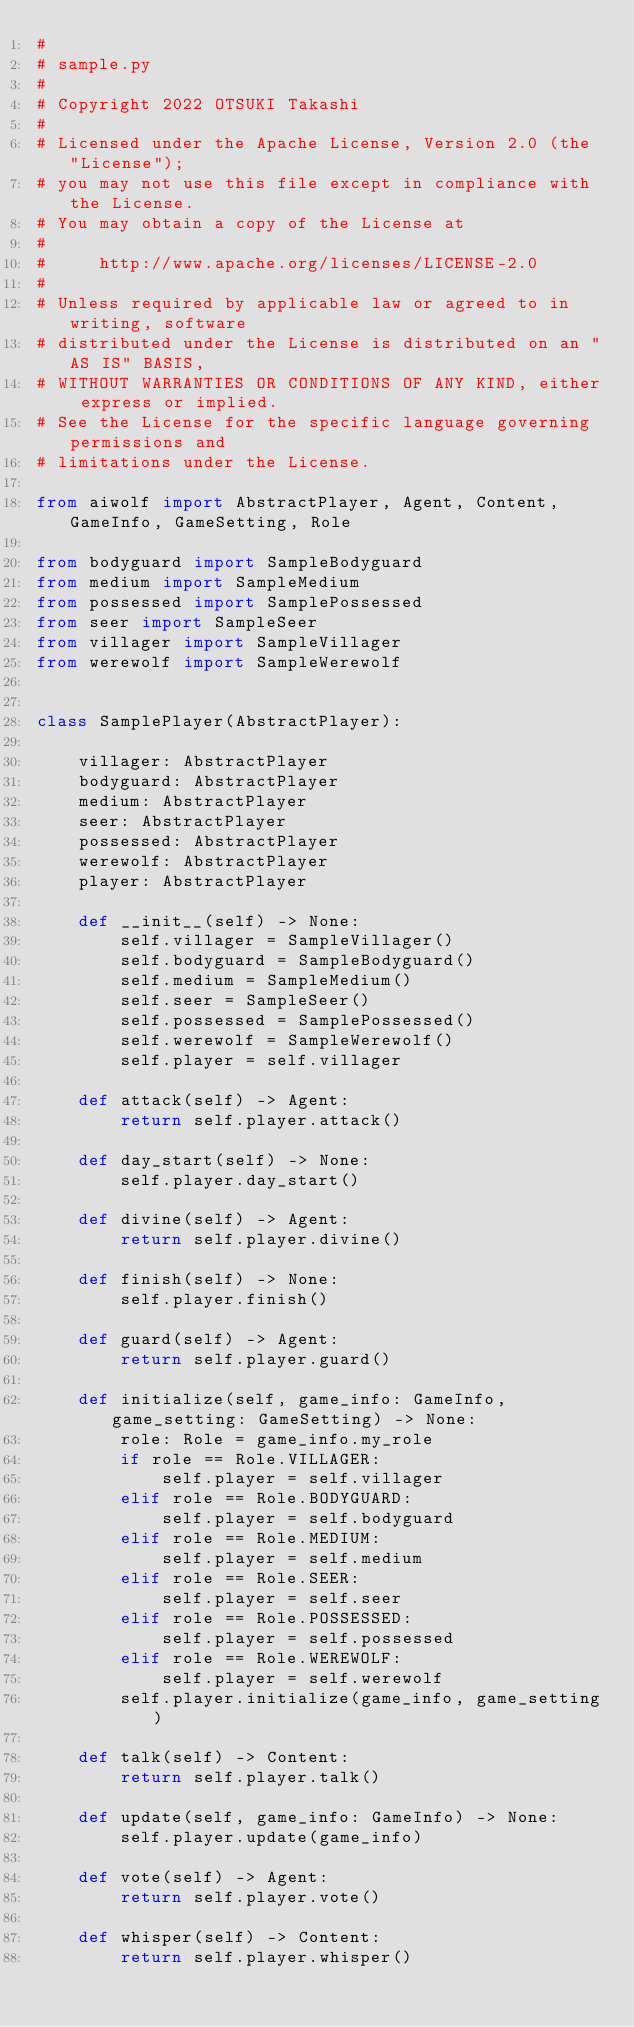Convert code to text. <code><loc_0><loc_0><loc_500><loc_500><_Python_>#
# sample.py
#
# Copyright 2022 OTSUKI Takashi
#
# Licensed under the Apache License, Version 2.0 (the "License");
# you may not use this file except in compliance with the License.
# You may obtain a copy of the License at
#
#     http://www.apache.org/licenses/LICENSE-2.0
#
# Unless required by applicable law or agreed to in writing, software
# distributed under the License is distributed on an "AS IS" BASIS,
# WITHOUT WARRANTIES OR CONDITIONS OF ANY KIND, either express or implied.
# See the License for the specific language governing permissions and
# limitations under the License.

from aiwolf import AbstractPlayer, Agent, Content, GameInfo, GameSetting, Role

from bodyguard import SampleBodyguard
from medium import SampleMedium
from possessed import SamplePossessed
from seer import SampleSeer
from villager import SampleVillager
from werewolf import SampleWerewolf


class SamplePlayer(AbstractPlayer):

    villager: AbstractPlayer
    bodyguard: AbstractPlayer
    medium: AbstractPlayer
    seer: AbstractPlayer
    possessed: AbstractPlayer
    werewolf: AbstractPlayer
    player: AbstractPlayer

    def __init__(self) -> None:
        self.villager = SampleVillager()
        self.bodyguard = SampleBodyguard()
        self.medium = SampleMedium()
        self.seer = SampleSeer()
        self.possessed = SamplePossessed()
        self.werewolf = SampleWerewolf()
        self.player = self.villager

    def attack(self) -> Agent:
        return self.player.attack()

    def day_start(self) -> None:
        self.player.day_start()

    def divine(self) -> Agent:
        return self.player.divine()

    def finish(self) -> None:
        self.player.finish()

    def guard(self) -> Agent:
        return self.player.guard()

    def initialize(self, game_info: GameInfo, game_setting: GameSetting) -> None:
        role: Role = game_info.my_role
        if role == Role.VILLAGER:
            self.player = self.villager
        elif role == Role.BODYGUARD:
            self.player = self.bodyguard
        elif role == Role.MEDIUM:
            self.player = self.medium
        elif role == Role.SEER:
            self.player = self.seer
        elif role == Role.POSSESSED:
            self.player = self.possessed
        elif role == Role.WEREWOLF:
            self.player = self.werewolf
        self.player.initialize(game_info, game_setting)

    def talk(self) -> Content:
        return self.player.talk()

    def update(self, game_info: GameInfo) -> None:
        self.player.update(game_info)

    def vote(self) -> Agent:
        return self.player.vote()

    def whisper(self) -> Content:
        return self.player.whisper()
</code> 